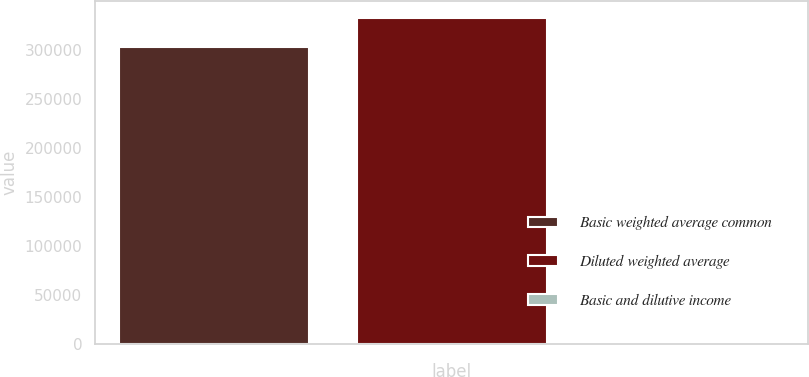Convert chart to OTSL. <chart><loc_0><loc_0><loc_500><loc_500><bar_chart><fcel>Basic weighted average common<fcel>Diluted weighted average<fcel>Basic and dilutive income<nl><fcel>302510<fcel>332761<fcel>0.47<nl></chart> 